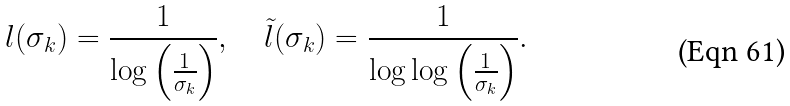Convert formula to latex. <formula><loc_0><loc_0><loc_500><loc_500>l ( \sigma _ { k } ) = \frac { 1 } { \log \left ( \frac { 1 } { \sigma _ { k } } \right ) } , \quad \tilde { l } ( \sigma _ { k } ) = \frac { 1 } { \log \log \left ( \frac { 1 } { \sigma _ { k } } \right ) } .</formula> 